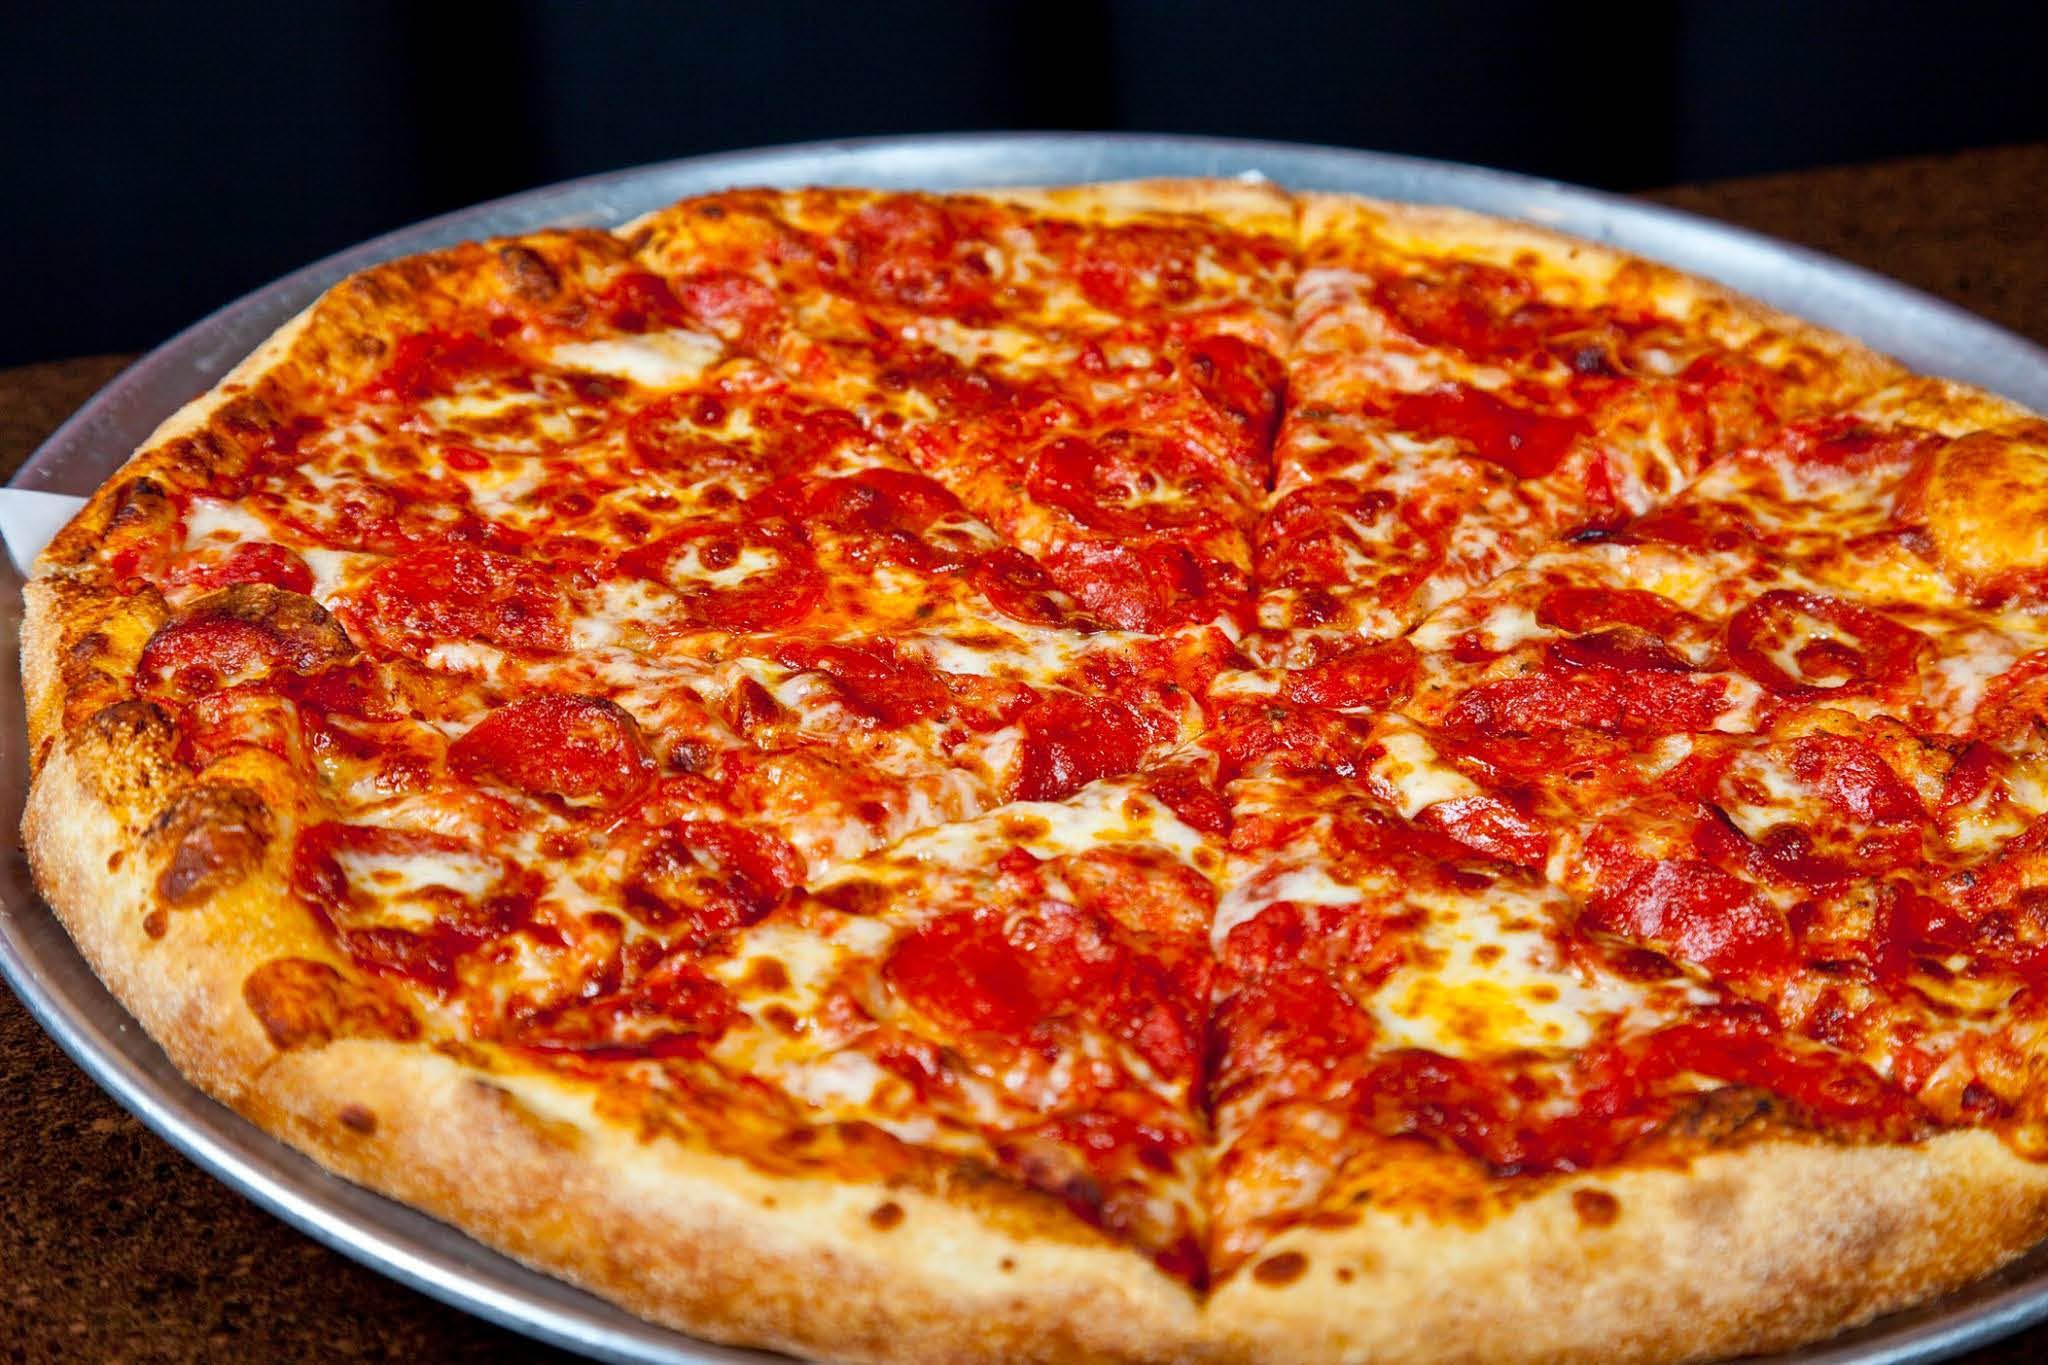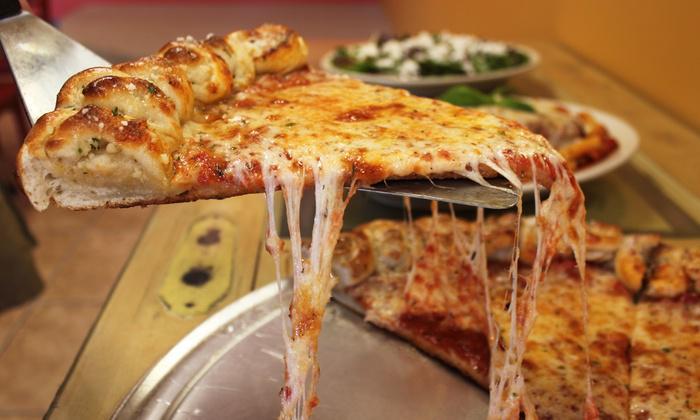The first image is the image on the left, the second image is the image on the right. Evaluate the accuracy of this statement regarding the images: "There are two whole pizzas.". Is it true? Answer yes or no. No. The first image is the image on the left, the second image is the image on the right. For the images displayed, is the sentence "In at least one image one slice of pizza has been separated from the rest of the pizza." factually correct? Answer yes or no. Yes. 